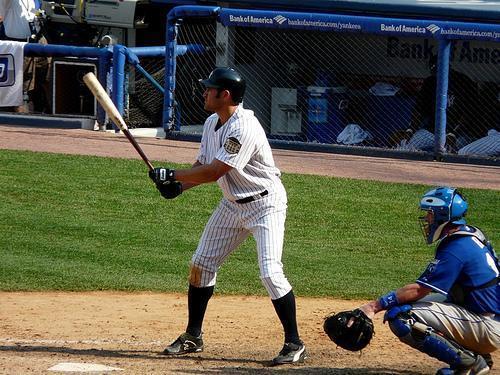How many people are there?
Give a very brief answer. 4. 